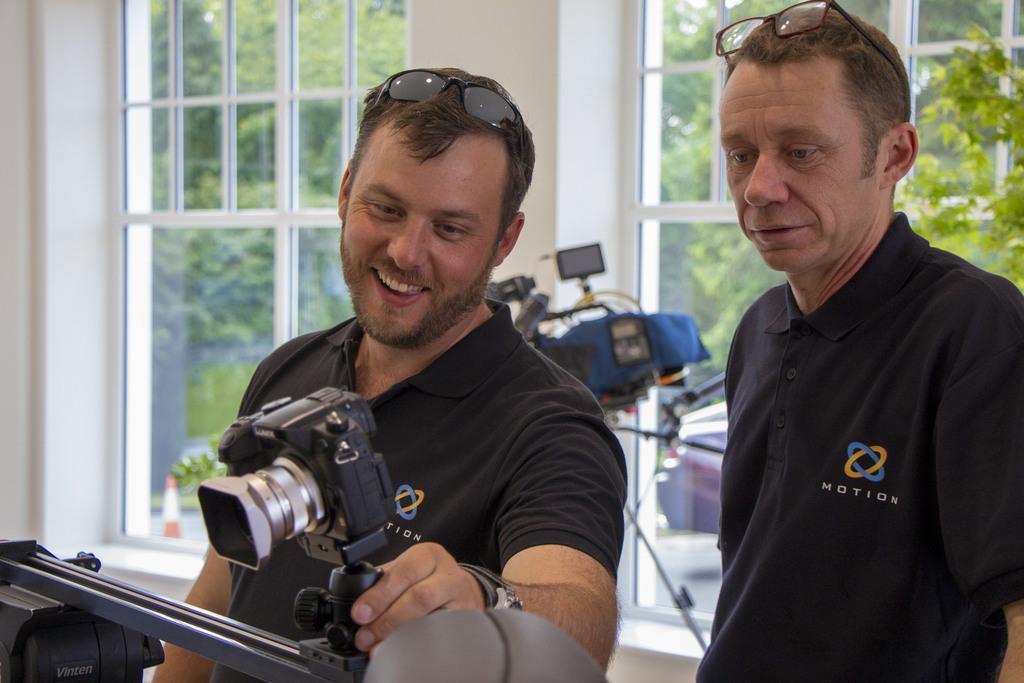Please provide a concise description of this image. These two persons are standing and this man is holding a camera. From this window we can able to see trees. 